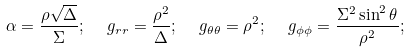Convert formula to latex. <formula><loc_0><loc_0><loc_500><loc_500>\alpha = \frac { \rho \sqrt { \Delta } } { \Sigma } ; \ \ g _ { r r } = \frac { \rho ^ { 2 } } { \Delta } ; \ \ g _ { \theta \theta } = \rho ^ { 2 } ; \ \ g _ { \phi \phi } = \frac { \Sigma ^ { 2 } \sin ^ { 2 } \theta } { \rho ^ { 2 } } ;</formula> 